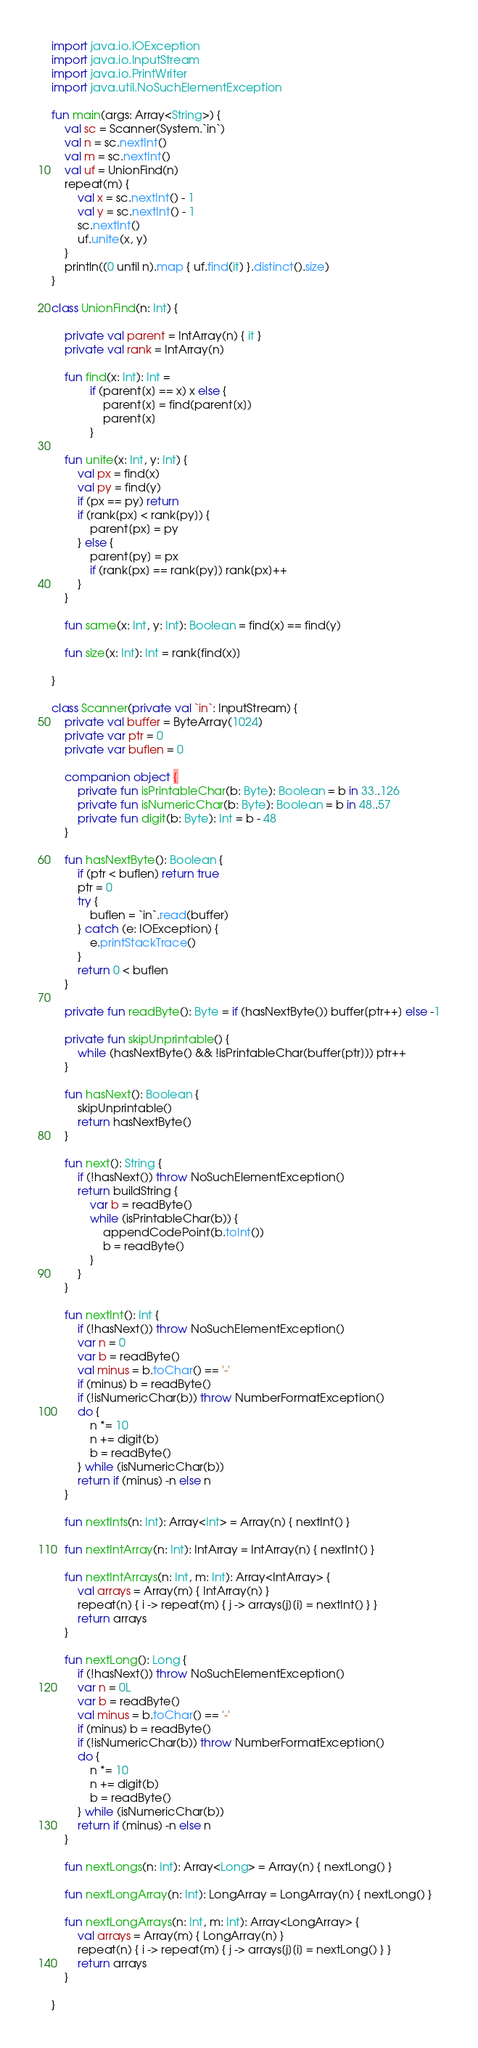<code> <loc_0><loc_0><loc_500><loc_500><_Kotlin_>import java.io.IOException
import java.io.InputStream
import java.io.PrintWriter
import java.util.NoSuchElementException

fun main(args: Array<String>) {
    val sc = Scanner(System.`in`)
    val n = sc.nextInt()
    val m = sc.nextInt()
    val uf = UnionFind(n)
    repeat(m) {
        val x = sc.nextInt() - 1
        val y = sc.nextInt() - 1
        sc.nextInt()
        uf.unite(x, y)
    }
    println((0 until n).map { uf.find(it) }.distinct().size)
}

class UnionFind(n: Int) {

    private val parent = IntArray(n) { it }
    private val rank = IntArray(n)

    fun find(x: Int): Int =
            if (parent[x] == x) x else {
                parent[x] = find(parent[x])
                parent[x]
            }

    fun unite(x: Int, y: Int) {
        val px = find(x)
        val py = find(y)
        if (px == py) return
        if (rank[px] < rank[py]) {
            parent[px] = py
        } else {
            parent[py] = px
            if (rank[px] == rank[py]) rank[px]++
        }
    }

    fun same(x: Int, y: Int): Boolean = find(x) == find(y)

    fun size(x: Int): Int = rank[find(x)]

}

class Scanner(private val `in`: InputStream) {
    private val buffer = ByteArray(1024)
    private var ptr = 0
    private var buflen = 0

    companion object {
        private fun isPrintableChar(b: Byte): Boolean = b in 33..126
        private fun isNumericChar(b: Byte): Boolean = b in 48..57
        private fun digit(b: Byte): Int = b - 48
    }

    fun hasNextByte(): Boolean {
        if (ptr < buflen) return true
        ptr = 0
        try {
            buflen = `in`.read(buffer)
        } catch (e: IOException) {
            e.printStackTrace()
        }
        return 0 < buflen
    }

    private fun readByte(): Byte = if (hasNextByte()) buffer[ptr++] else -1

    private fun skipUnprintable() {
        while (hasNextByte() && !isPrintableChar(buffer[ptr])) ptr++
    }

    fun hasNext(): Boolean {
        skipUnprintable()
        return hasNextByte()
    }

    fun next(): String {
        if (!hasNext()) throw NoSuchElementException()
        return buildString {
            var b = readByte()
            while (isPrintableChar(b)) {
                appendCodePoint(b.toInt())
                b = readByte()
            }
        }
    }

    fun nextInt(): Int {
        if (!hasNext()) throw NoSuchElementException()
        var n = 0
        var b = readByte()
        val minus = b.toChar() == '-'
        if (minus) b = readByte()
        if (!isNumericChar(b)) throw NumberFormatException()
        do {
            n *= 10
            n += digit(b)
            b = readByte()
        } while (isNumericChar(b))
        return if (minus) -n else n
    }

    fun nextInts(n: Int): Array<Int> = Array(n) { nextInt() }

    fun nextIntArray(n: Int): IntArray = IntArray(n) { nextInt() }

    fun nextIntArrays(n: Int, m: Int): Array<IntArray> {
        val arrays = Array(m) { IntArray(n) }
        repeat(n) { i -> repeat(m) { j -> arrays[j][i] = nextInt() } }
        return arrays
    }

    fun nextLong(): Long {
        if (!hasNext()) throw NoSuchElementException()
        var n = 0L
        var b = readByte()
        val minus = b.toChar() == '-'
        if (minus) b = readByte()
        if (!isNumericChar(b)) throw NumberFormatException()
        do {
            n *= 10
            n += digit(b)
            b = readByte()
        } while (isNumericChar(b))
        return if (minus) -n else n
    }

    fun nextLongs(n: Int): Array<Long> = Array(n) { nextLong() }

    fun nextLongArray(n: Int): LongArray = LongArray(n) { nextLong() }

    fun nextLongArrays(n: Int, m: Int): Array<LongArray> {
        val arrays = Array(m) { LongArray(n) }
        repeat(n) { i -> repeat(m) { j -> arrays[j][i] = nextLong() } }
        return arrays
    }

}</code> 